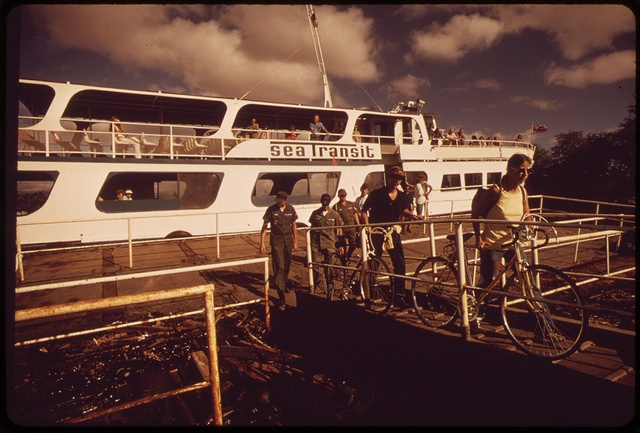Describe the objects in this image and their specific colors. I can see boat in black, tan, maroon, and brown tones, bicycle in black, maroon, and brown tones, people in black, maroon, brown, and tan tones, people in black, maroon, and brown tones, and bicycle in black, maroon, and brown tones in this image. 